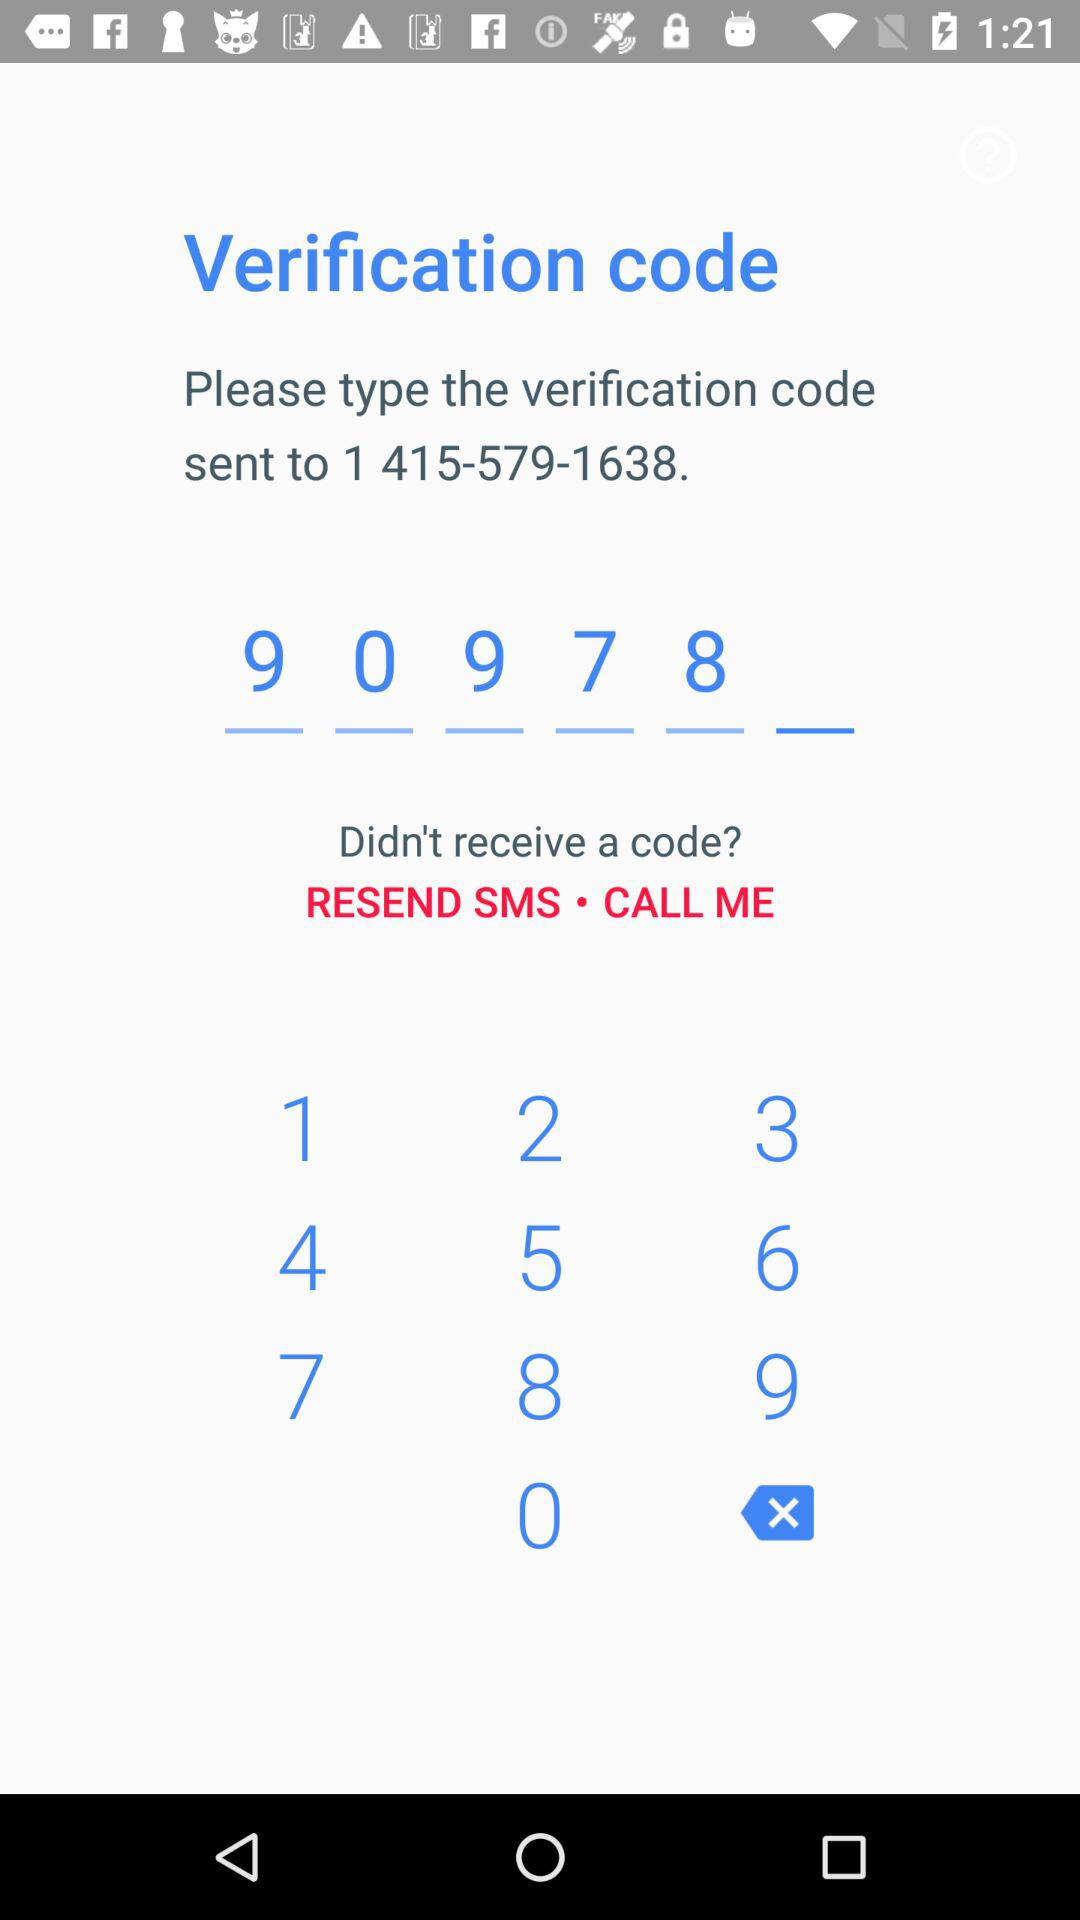How many numbers are in the verification code?
Answer the question using a single word or phrase. 6 